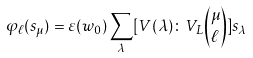Convert formula to latex. <formula><loc_0><loc_0><loc_500><loc_500>\varphi _ { \ell } ( s _ { \mu } ) = \varepsilon ( w _ { 0 } ) \sum _ { \lambda } [ V ( \lambda ) \colon V _ { L } \binom { \mu } { \ell } ] s _ { \lambda }</formula> 